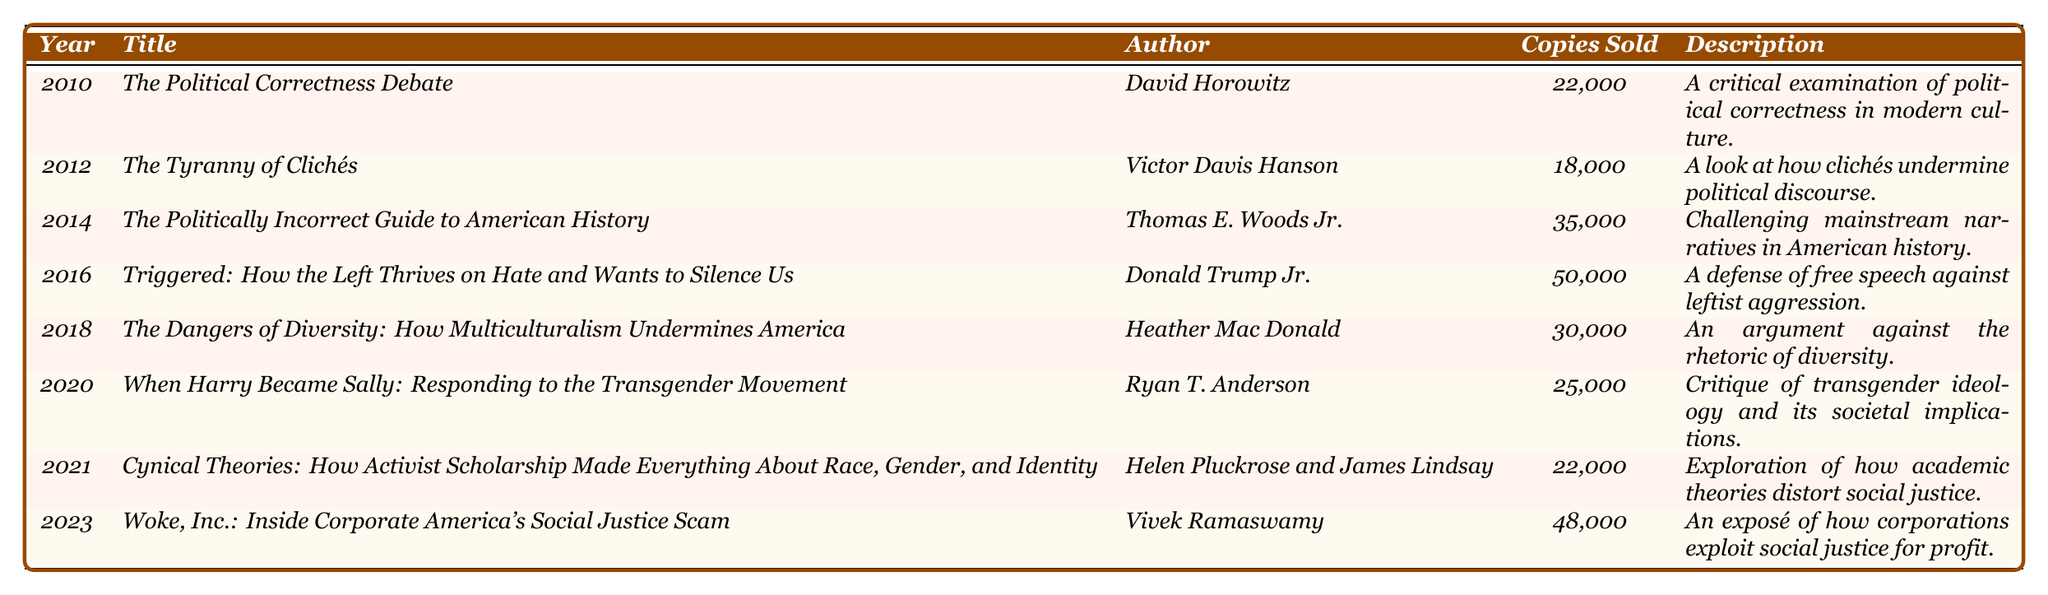What was the highest number of copies sold in a single year for politically themed literature? The table shows that in 2016, the book "Triggered: How the Left Thrives on Hate and Wants to Silence Us" by Donald Trump Jr. sold the most copies, totaling 50,000.
Answer: 50,000 Which book had the least copies sold, and how many were sold? According to the table, the book with the least copies sold is "The Tyranny of Clichés" by Victor Davis Hanson, with 18,000 copies sold.
Answer: 18,000 How many copies were sold in total from 2010 to 2023? To find the total, sum the copies sold: 22,000 + 18,000 + 35,000 + 50,000 + 30,000 + 25,000 + 22,000 + 48,000 = 250,000 copies sold in total.
Answer: 250,000 What is the average number of copies sold per year from the provided data? There are 8 data points (years). The total number of copies sold is 250,000. Dividing this by the number of years gives 250,000 / 8 = 31,250.
Answer: 31,250 Did any books released after 2016 sell fewer copies than the least selling book before that year? The least selling book before 2017 is "The Tyranny of Clichés" with 18,000 copies sold. The books released after 2016 are "When Harry Became Sally" (25,000) and "Cynical Theories" (22,000), both of which sold more than 18,000. Therefore, no books released after 2016 sold fewer copies.
Answer: No What is the change in copies sold from the best-selling book in 2016 to the best-selling book in 2023? The best-selling book in 2016 is "Triggered" with 50,000 copies. The best-selling book in 2023 is "Woke, Inc." with 48,000 copies. The difference is 50,000 - 48,000 = 2,000 copies.
Answer: 2,000 Which genre had the most significant representation in terms of copies sold? To determine this, we need to summarize the copies sold by genre: "Political Commentary" (22,000 + 18,000 + 50,000 = 90,000), "Historical Analysis" (35,000), "Sociopolitical Analysis" (30,000 + 25,000 = 55,000), "Cultural Critique" (22,000), "Business and Politics" (48,000). The highest is "Political Commentary" with 90,000.
Answer: Political Commentary 